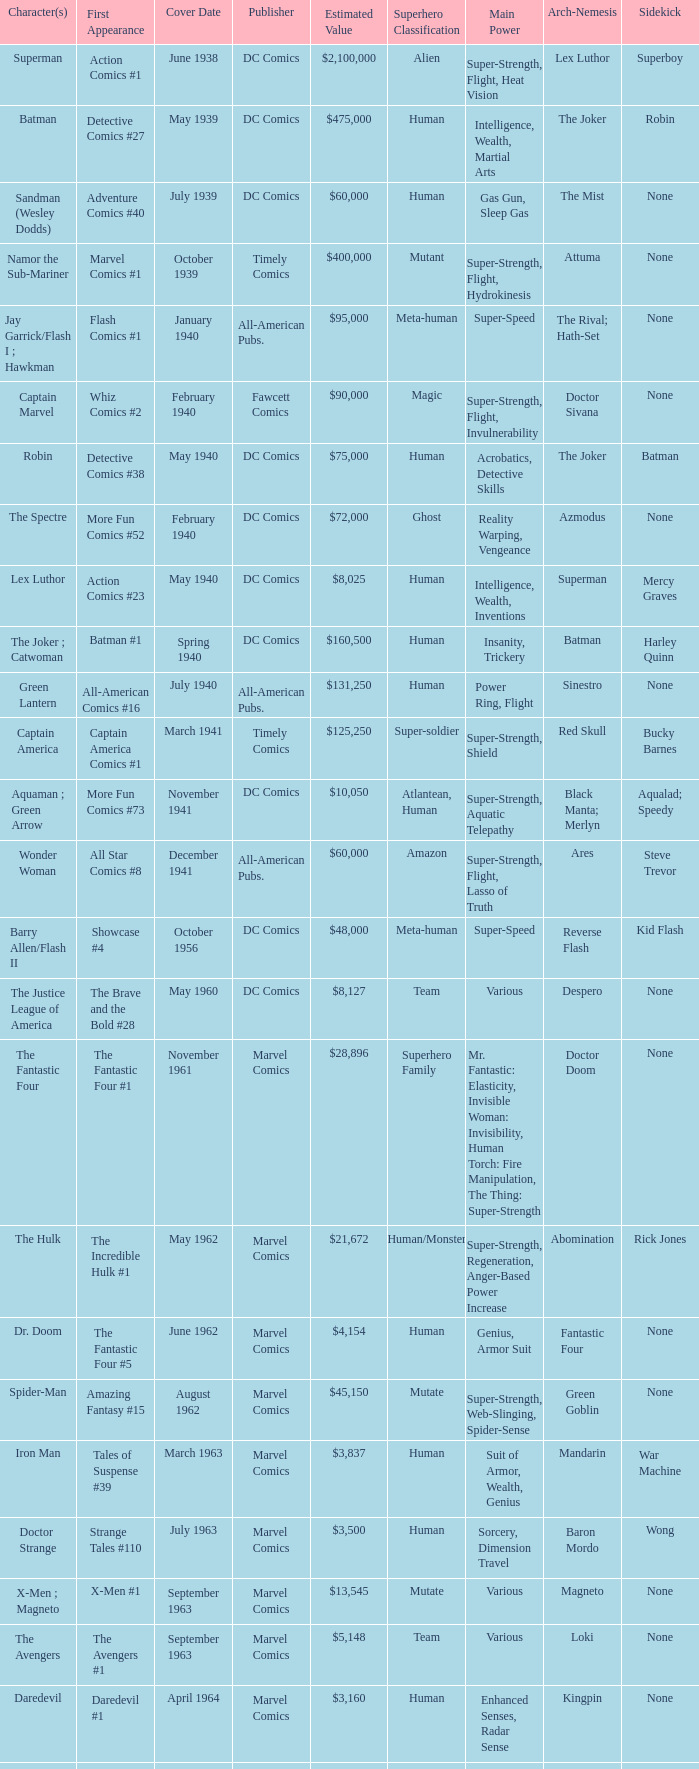In amazing fantasy #15, which character made their first appearance? Spider-Man. 